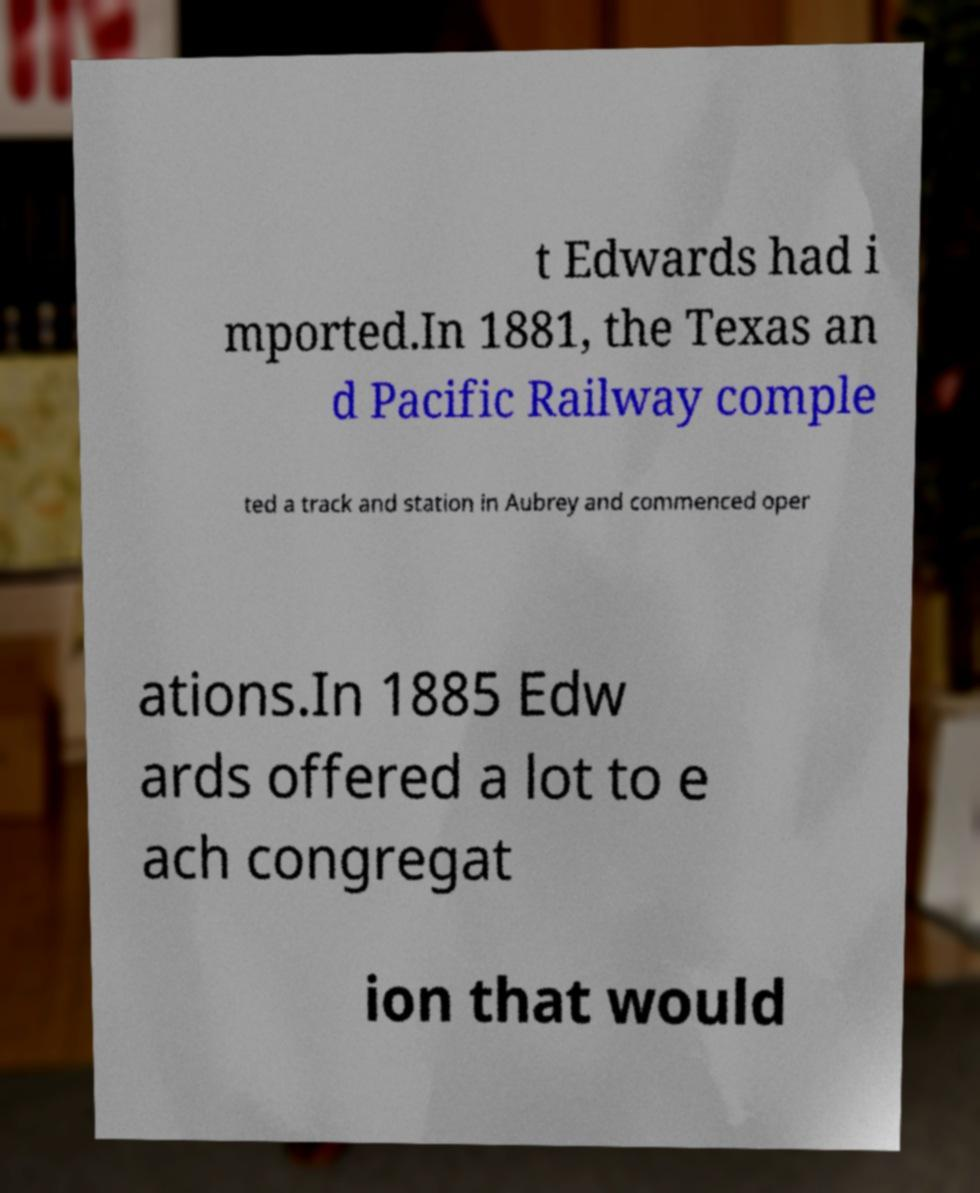Could you assist in decoding the text presented in this image and type it out clearly? t Edwards had i mported.In 1881, the Texas an d Pacific Railway comple ted a track and station in Aubrey and commenced oper ations.In 1885 Edw ards offered a lot to e ach congregat ion that would 